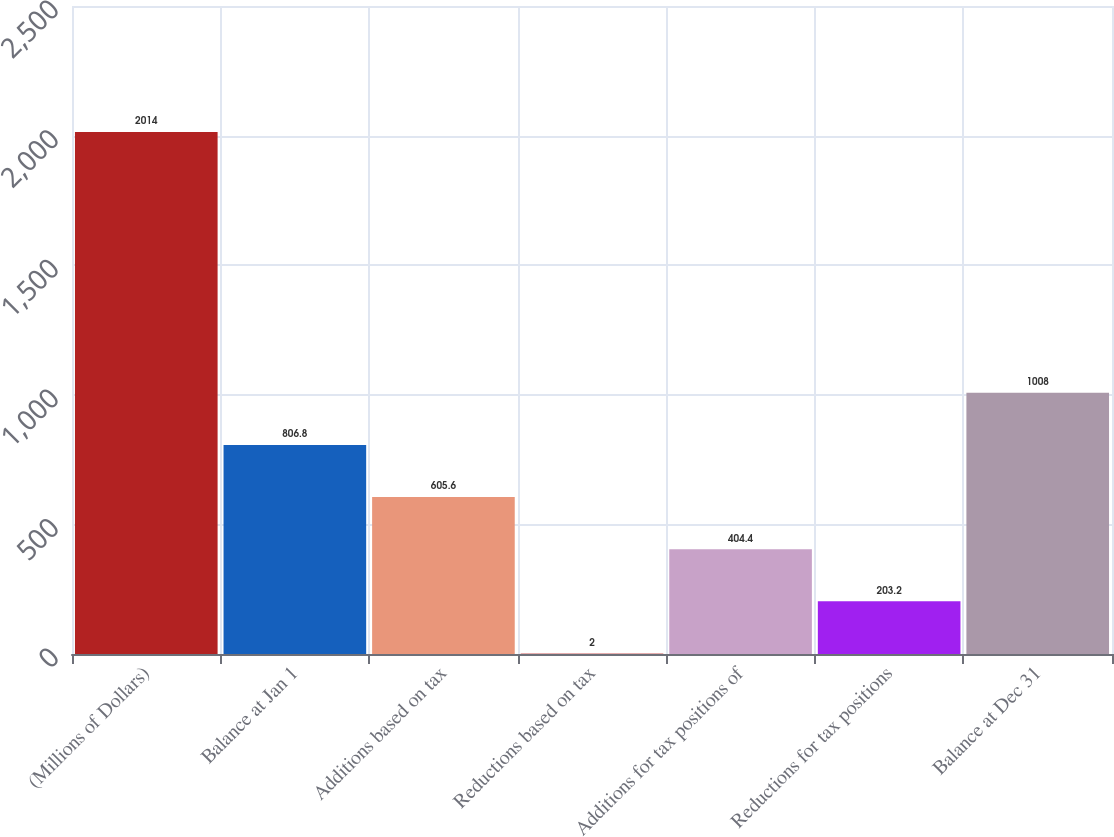Convert chart. <chart><loc_0><loc_0><loc_500><loc_500><bar_chart><fcel>(Millions of Dollars)<fcel>Balance at Jan 1<fcel>Additions based on tax<fcel>Reductions based on tax<fcel>Additions for tax positions of<fcel>Reductions for tax positions<fcel>Balance at Dec 31<nl><fcel>2014<fcel>806.8<fcel>605.6<fcel>2<fcel>404.4<fcel>203.2<fcel>1008<nl></chart> 